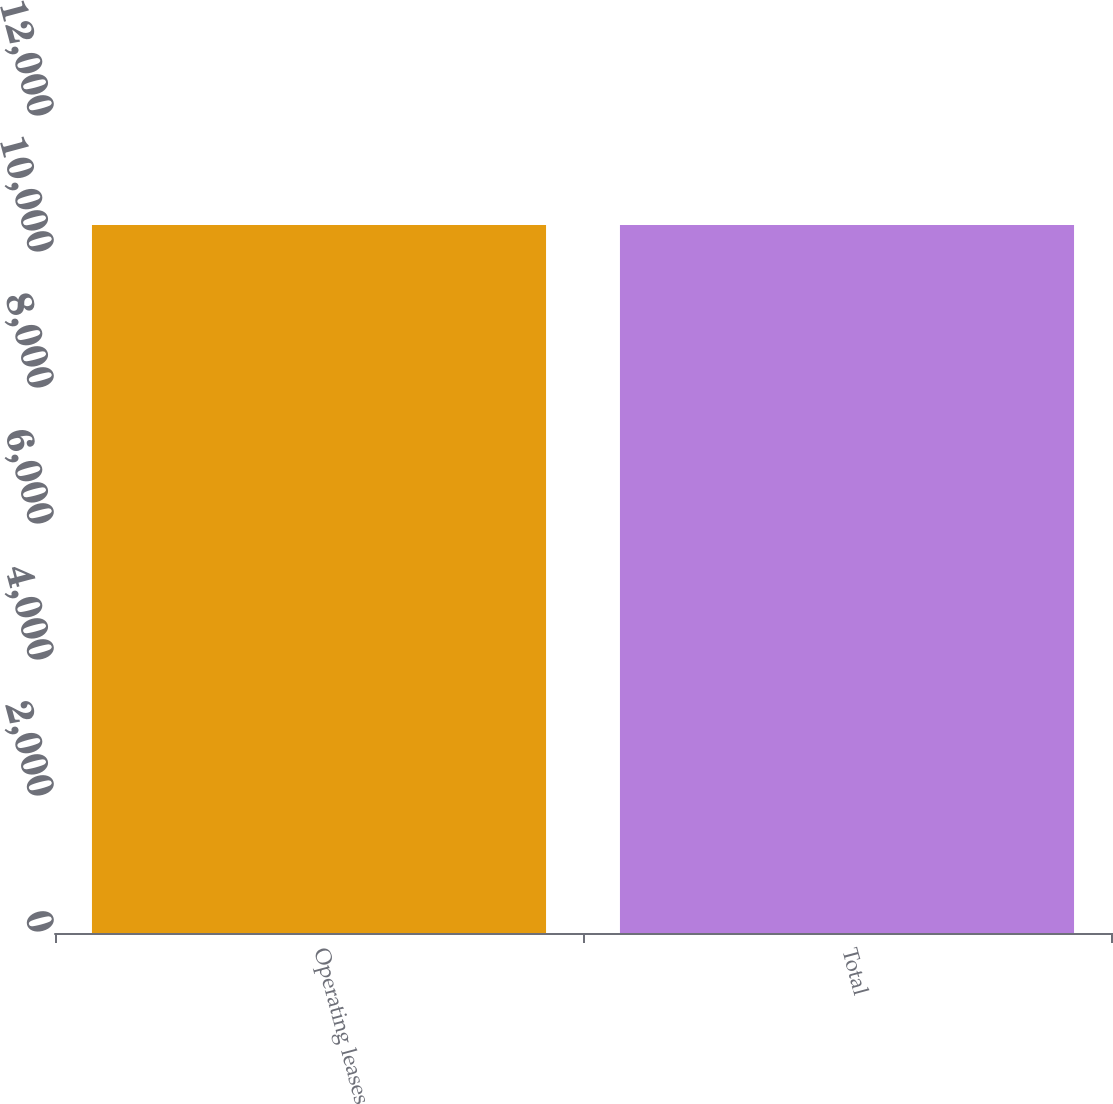Convert chart. <chart><loc_0><loc_0><loc_500><loc_500><bar_chart><fcel>Operating leases<fcel>Total<nl><fcel>10410<fcel>10410.1<nl></chart> 